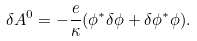Convert formula to latex. <formula><loc_0><loc_0><loc_500><loc_500>\delta A ^ { 0 } = - { \frac { e } { \kappa } } ( \phi ^ { * } \delta \phi + \delta \phi ^ { * } \phi ) .</formula> 